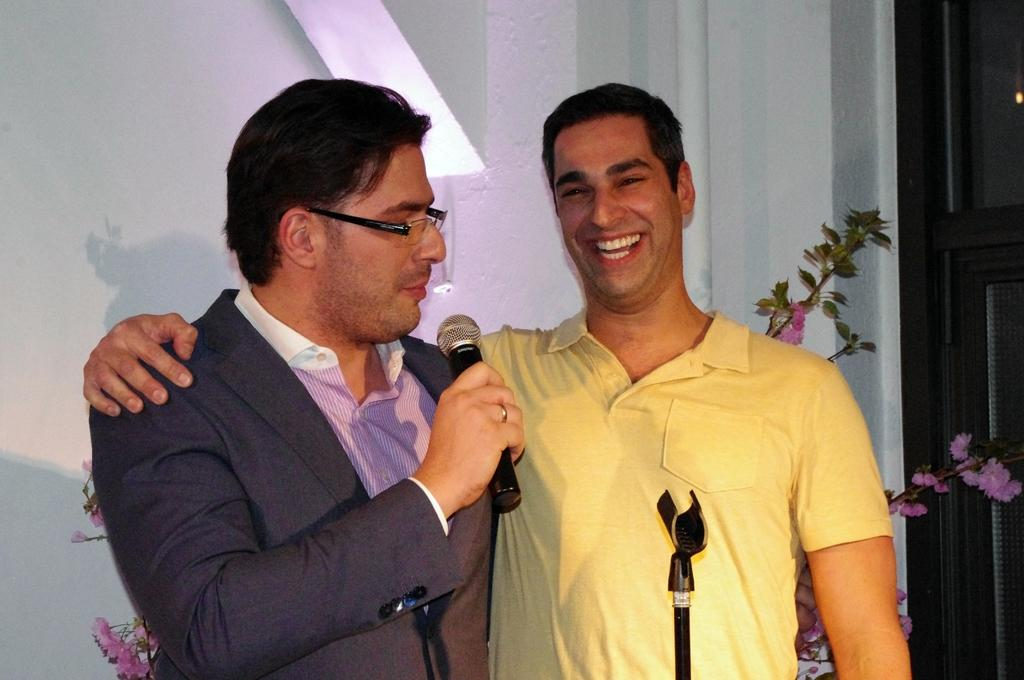How many people are in the image? There are two persons in the image. What is one of the persons holding? One person is holding a microphone. What type of linen is being exchanged between the two persons in the image? There is no linen present in the image, nor is there any exchange happening between the two persons. 